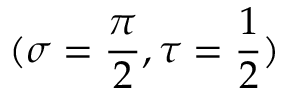Convert formula to latex. <formula><loc_0><loc_0><loc_500><loc_500>( \sigma = \frac { \pi } { 2 } , \tau = \frac { 1 } { 2 } )</formula> 